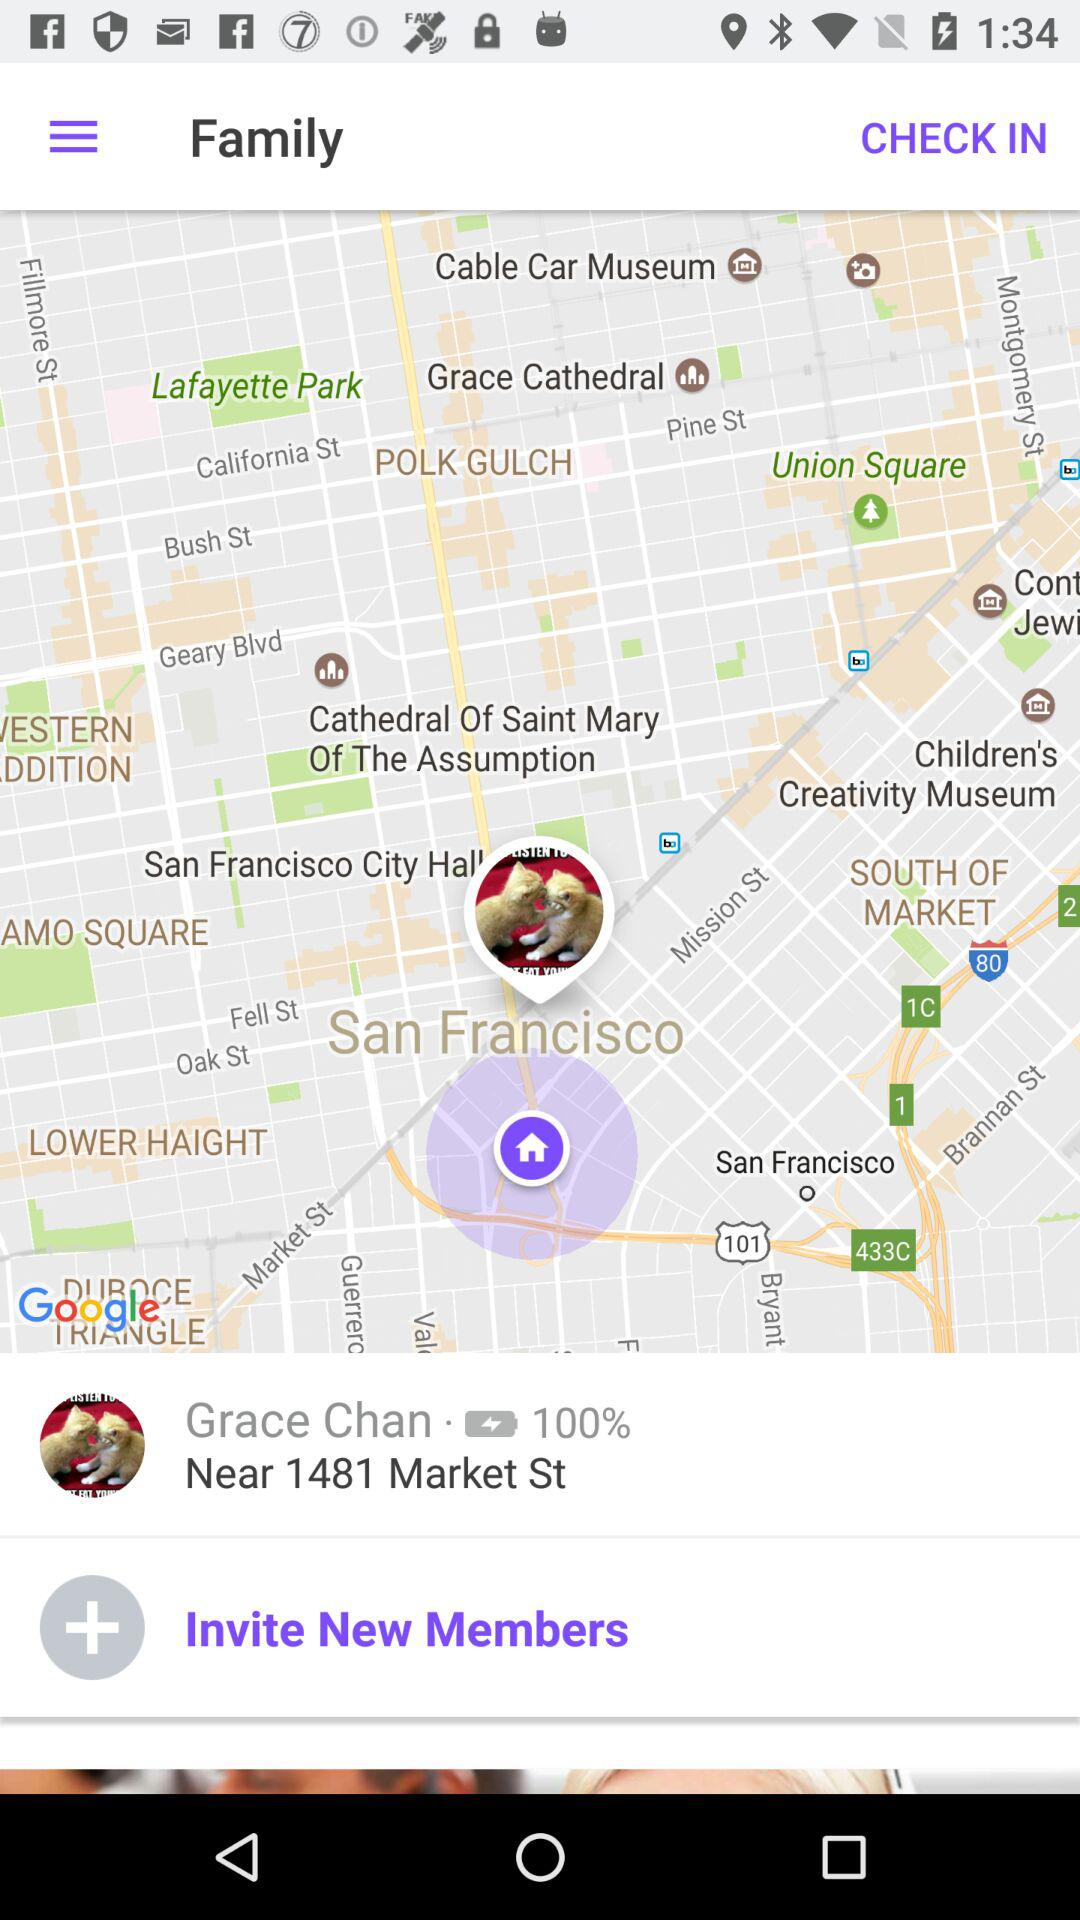What is the address given on the screen? The given address is near 1481 Market St. 